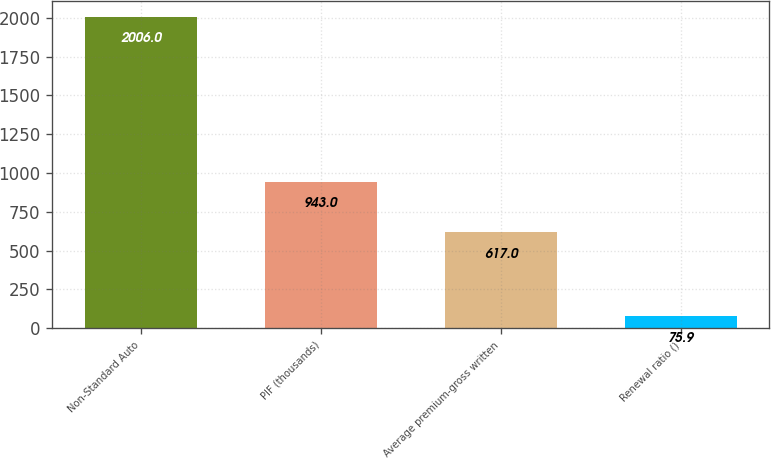Convert chart. <chart><loc_0><loc_0><loc_500><loc_500><bar_chart><fcel>Non-Standard Auto<fcel>PIF (thousands)<fcel>Average premium-gross written<fcel>Renewal ratio ()<nl><fcel>2006<fcel>943<fcel>617<fcel>75.9<nl></chart> 